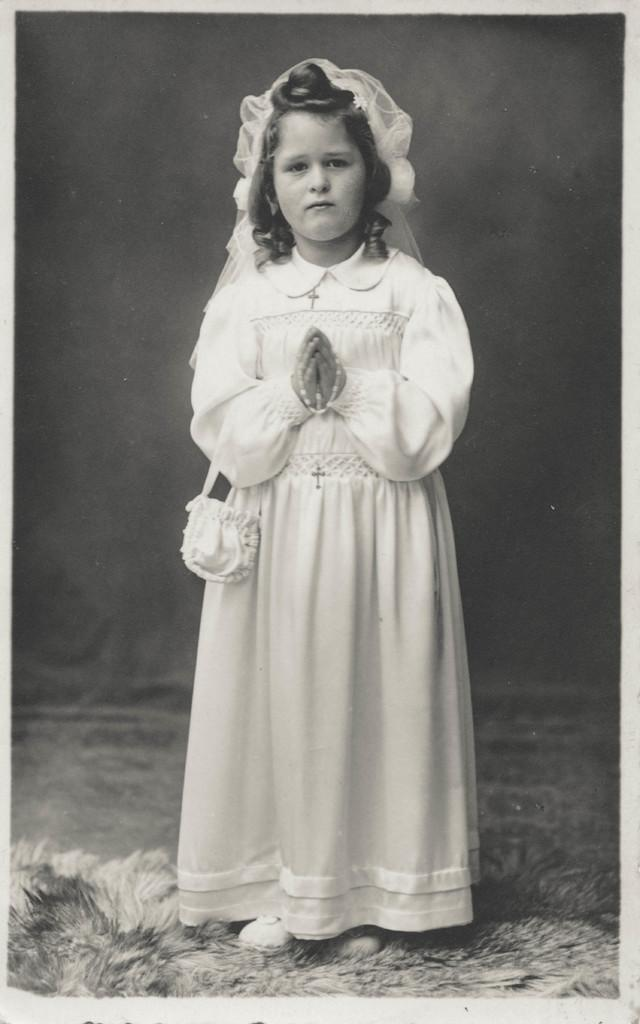Who is the main subject in the image? There is a girl in the image. What is the color scheme of the image? The image is black and white. What type of limit is being imposed on the girl in the image? There is no indication of any limit being imposed on the girl in the image. What kind of adjustment is the girl making in the image? There is no adjustment being made by the girl in the image. What instrument is the girl playing in the image? There is no instrument present in the image. 